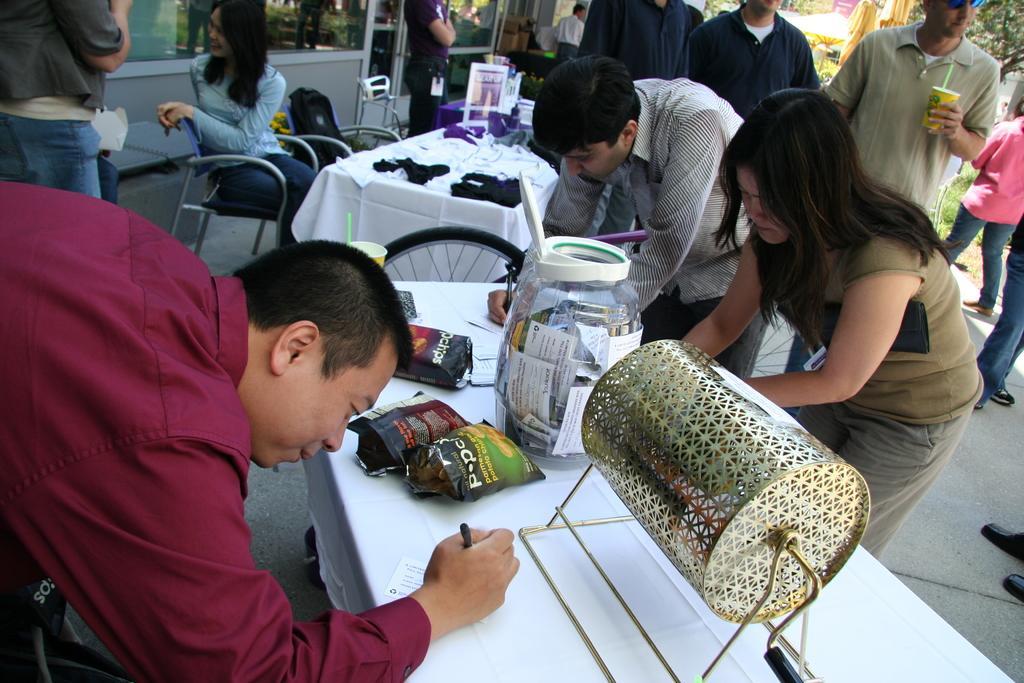In one or two sentences, can you explain what this image depicts? In this picture we can see group of people, few are standing and a woman is sitting on the chair, in front of her we can see few packets, jar, a machine and other things on the tables, on the right side of the image we can see a man, he is holding a cup, in the background we can find few trees. 